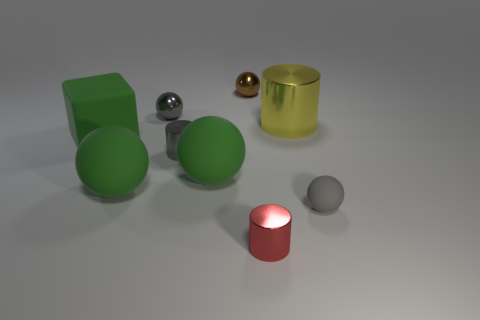Subtract all large spheres. How many spheres are left? 3 Add 1 large cyan matte blocks. How many objects exist? 10 Subtract all cylinders. How many objects are left? 6 Subtract all green balls. How many balls are left? 3 Subtract 2 balls. How many balls are left? 3 Subtract all brown blocks. How many brown cylinders are left? 0 Subtract all purple rubber cylinders. Subtract all large shiny cylinders. How many objects are left? 8 Add 1 tiny brown shiny things. How many tiny brown shiny things are left? 2 Add 5 small gray matte spheres. How many small gray matte spheres exist? 6 Subtract 0 cyan cylinders. How many objects are left? 9 